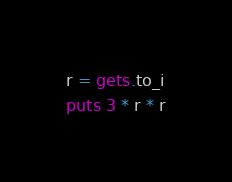<code> <loc_0><loc_0><loc_500><loc_500><_Ruby_>r = gets.to_i
puts 3 * r * r</code> 